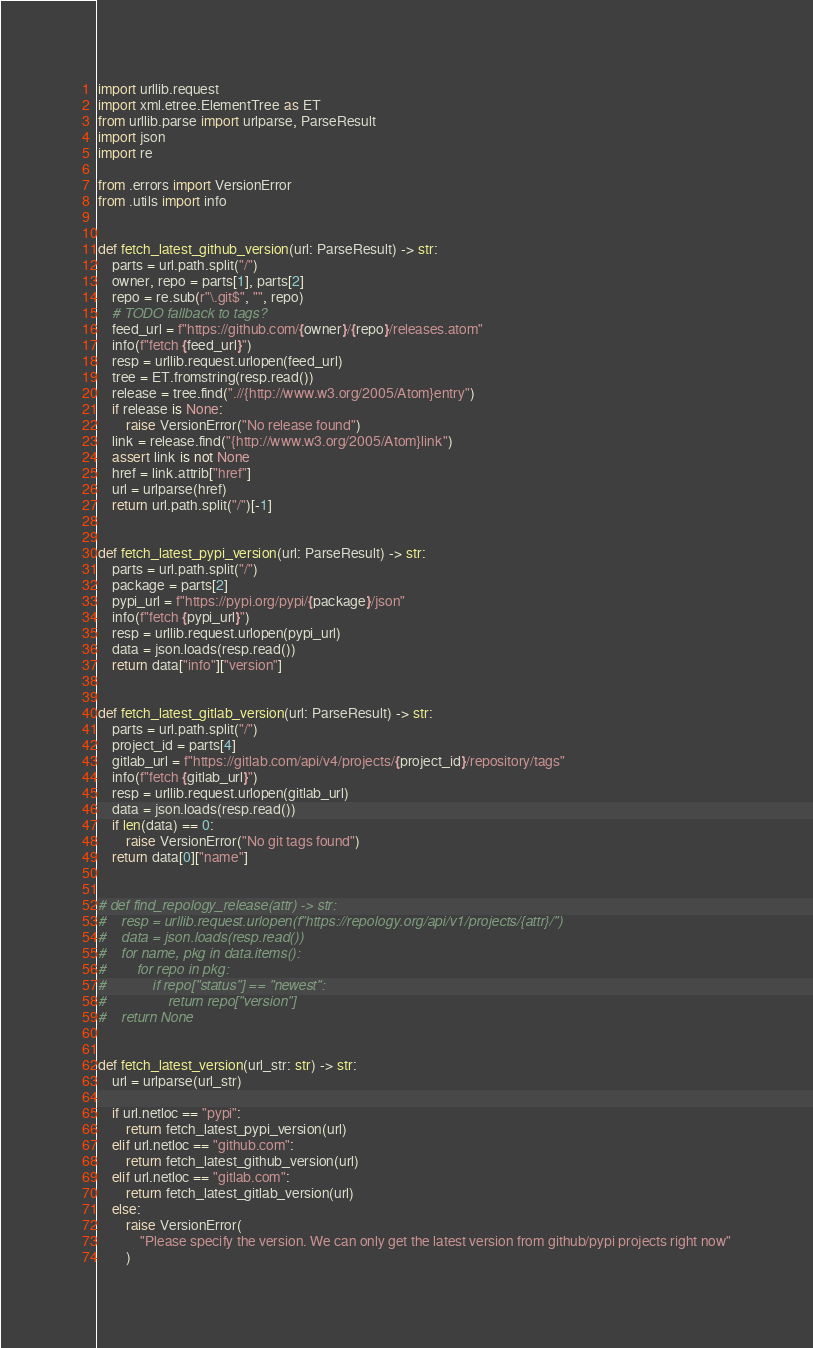Convert code to text. <code><loc_0><loc_0><loc_500><loc_500><_Python_>import urllib.request
import xml.etree.ElementTree as ET
from urllib.parse import urlparse, ParseResult
import json
import re

from .errors import VersionError
from .utils import info


def fetch_latest_github_version(url: ParseResult) -> str:
    parts = url.path.split("/")
    owner, repo = parts[1], parts[2]
    repo = re.sub(r"\.git$", "", repo)
    # TODO fallback to tags?
    feed_url = f"https://github.com/{owner}/{repo}/releases.atom"
    info(f"fetch {feed_url}")
    resp = urllib.request.urlopen(feed_url)
    tree = ET.fromstring(resp.read())
    release = tree.find(".//{http://www.w3.org/2005/Atom}entry")
    if release is None:
        raise VersionError("No release found")
    link = release.find("{http://www.w3.org/2005/Atom}link")
    assert link is not None
    href = link.attrib["href"]
    url = urlparse(href)
    return url.path.split("/")[-1]


def fetch_latest_pypi_version(url: ParseResult) -> str:
    parts = url.path.split("/")
    package = parts[2]
    pypi_url = f"https://pypi.org/pypi/{package}/json"
    info(f"fetch {pypi_url}")
    resp = urllib.request.urlopen(pypi_url)
    data = json.loads(resp.read())
    return data["info"]["version"]


def fetch_latest_gitlab_version(url: ParseResult) -> str:
    parts = url.path.split("/")
    project_id = parts[4]
    gitlab_url = f"https://gitlab.com/api/v4/projects/{project_id}/repository/tags"
    info(f"fetch {gitlab_url}")
    resp = urllib.request.urlopen(gitlab_url)
    data = json.loads(resp.read())
    if len(data) == 0:
        raise VersionError("No git tags found")
    return data[0]["name"]


# def find_repology_release(attr) -> str:
#    resp = urllib.request.urlopen(f"https://repology.org/api/v1/projects/{attr}/")
#    data = json.loads(resp.read())
#    for name, pkg in data.items():
#        for repo in pkg:
#            if repo["status"] == "newest":
#                return repo["version"]
#    return None


def fetch_latest_version(url_str: str) -> str:
    url = urlparse(url_str)

    if url.netloc == "pypi":
        return fetch_latest_pypi_version(url)
    elif url.netloc == "github.com":
        return fetch_latest_github_version(url)
    elif url.netloc == "gitlab.com":
        return fetch_latest_gitlab_version(url)
    else:
        raise VersionError(
            "Please specify the version. We can only get the latest version from github/pypi projects right now"
        )
</code> 